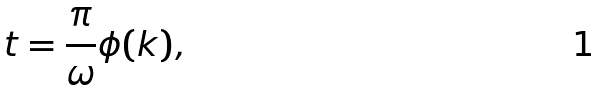Convert formula to latex. <formula><loc_0><loc_0><loc_500><loc_500>t = \frac { \pi } { \omega } \phi ( k ) ,</formula> 